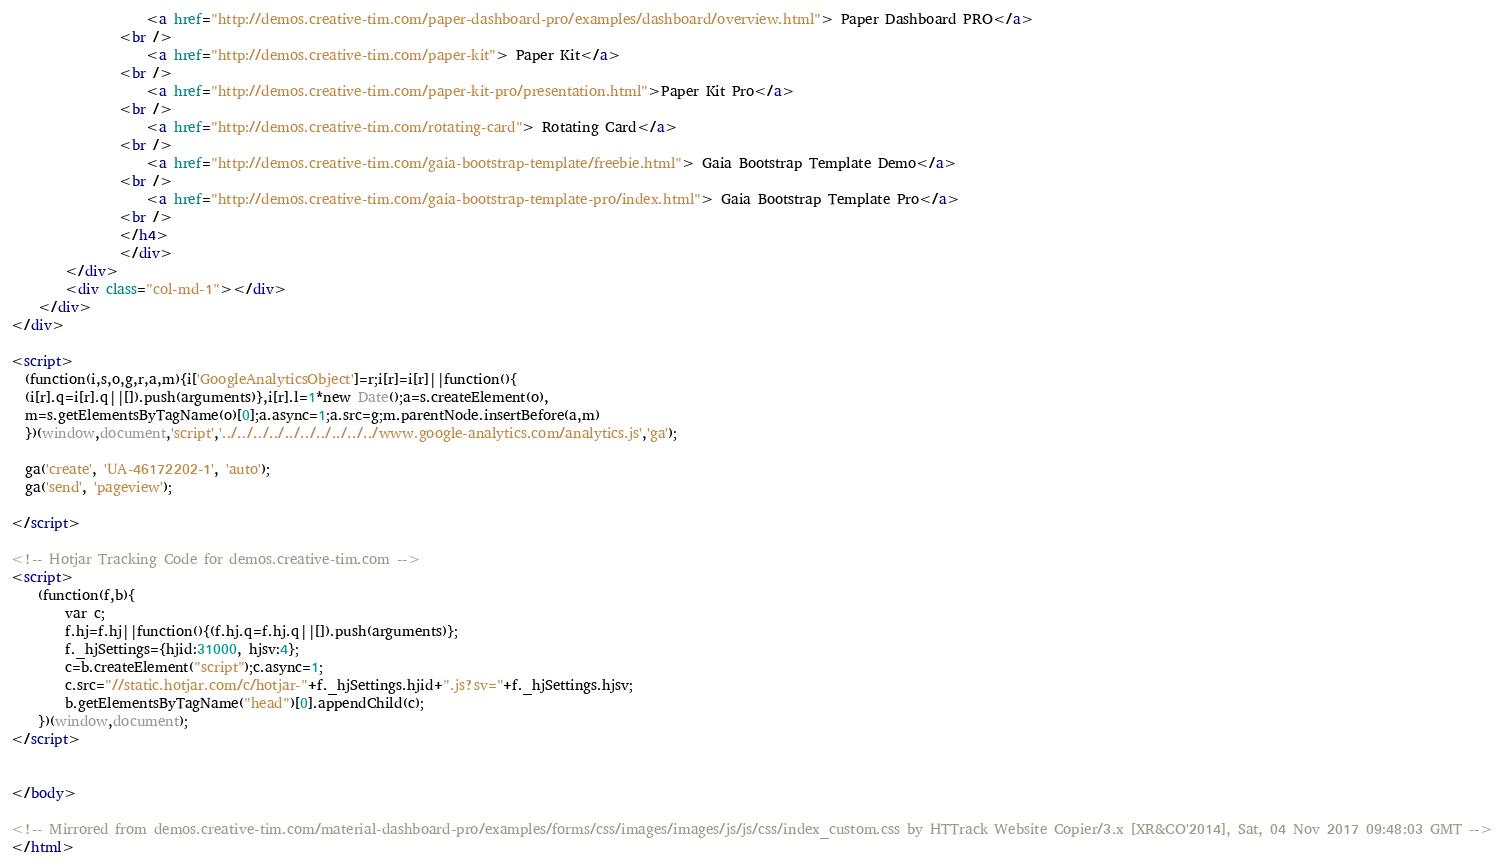<code> <loc_0><loc_0><loc_500><loc_500><_HTML_>				    <a href="http://demos.creative-tim.com/paper-dashboard-pro/examples/dashboard/overview.html"> Paper Dashboard PRO</a>
				<br />
                    <a href="http://demos.creative-tim.com/paper-kit"> Paper Kit</a>
				<br />
                    <a href="http://demos.creative-tim.com/paper-kit-pro/presentation.html">Paper Kit Pro</a>
                <br />
                    <a href="http://demos.creative-tim.com/rotating-card"> Rotating Card</a>
				<br />
					<a href="http://demos.creative-tim.com/gaia-bootstrap-template/freebie.html"> Gaia Bootstrap Template Demo</a>
                <br />
					<a href="http://demos.creative-tim.com/gaia-bootstrap-template-pro/index.html"> Gaia Bootstrap Template Pro</a>
				<br />
                </h4>
                </div>
        </div>
        <div class="col-md-1"></div>
    </div>
</div>

<script>
  (function(i,s,o,g,r,a,m){i['GoogleAnalyticsObject']=r;i[r]=i[r]||function(){
  (i[r].q=i[r].q||[]).push(arguments)},i[r].l=1*new Date();a=s.createElement(o),
  m=s.getElementsByTagName(o)[0];a.async=1;a.src=g;m.parentNode.insertBefore(a,m)
  })(window,document,'script','../../../../../../../../../../www.google-analytics.com/analytics.js','ga');

  ga('create', 'UA-46172202-1', 'auto');
  ga('send', 'pageview');

</script>

<!-- Hotjar Tracking Code for demos.creative-tim.com -->
<script>
    (function(f,b){
        var c;
        f.hj=f.hj||function(){(f.hj.q=f.hj.q||[]).push(arguments)};
        f._hjSettings={hjid:31000, hjsv:4};
        c=b.createElement("script");c.async=1;
        c.src="//static.hotjar.com/c/hotjar-"+f._hjSettings.hjid+".js?sv="+f._hjSettings.hjsv;
        b.getElementsByTagName("head")[0].appendChild(c);
    })(window,document);
</script>


</body>

<!-- Mirrored from demos.creative-tim.com/material-dashboard-pro/examples/forms/css/images/images/js/js/css/index_custom.css by HTTrack Website Copier/3.x [XR&CO'2014], Sat, 04 Nov 2017 09:48:03 GMT -->
</html>
</code> 